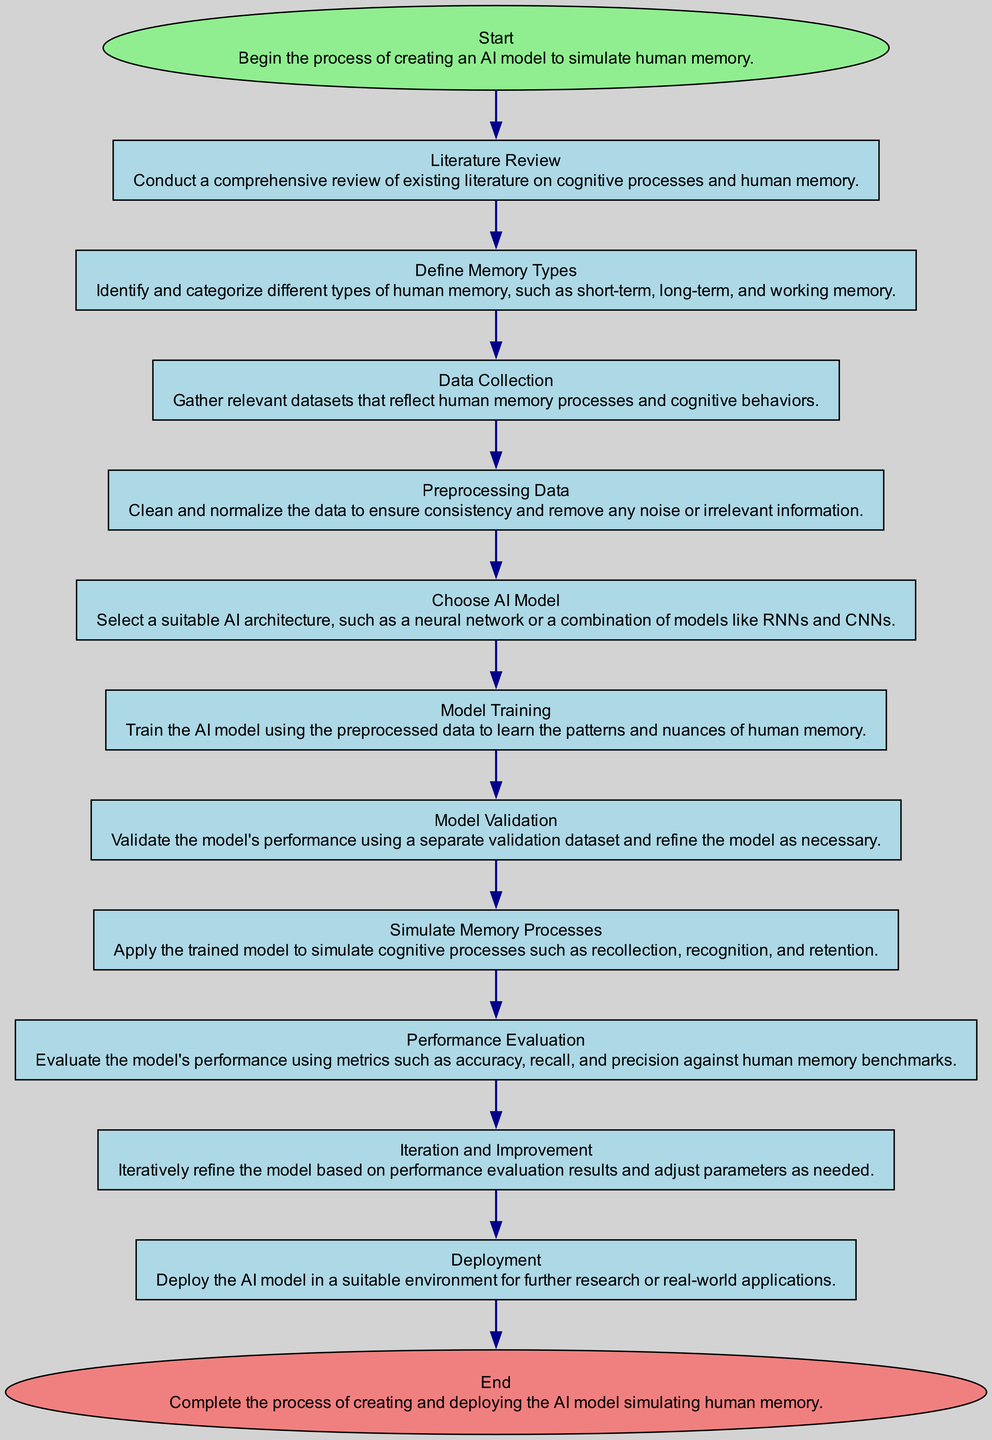What is the starting point of the flowchart? The starting point of the flowchart is identified as the first element, which is labeled "Start". This initiates the entire process of creating an AI model to simulate human memory.
Answer: Start How many nodes are in the diagram? There are a total of thirteen nodes in the diagram, each representing a distinct step in the process, from "Start" to "End".
Answer: Thirteen What is the task following "Data Collection"? The task following "Data Collection" is "Preprocessing Data". This indicates that after gathering the datasets, the next step is to clean and normalize the data.
Answer: Preprocessing Data Which two nodes are directly connected by an edge after "Model Training"? The two nodes directly connected by an edge after "Model Training" are "Model Validation" and "Model Training". The flow progresses from training the model to validating its performance.
Answer: Model Validation In what shape is the "End" node represented? The "End" node is represented in an ellipse shape, distinguishing it as the final stage of the flowchart. Ellipses are generally used to indicate the start and end of processes.
Answer: Ellipse Which step precedes "Simulate Memory Processes"? The step that precedes "Simulate Memory Processes" is "Model Validation". This means that before simulating cognitive processes, the model must first be validated.
Answer: Model Validation What is the last step in creating the AI model? The last step in creating the AI model is "End". This marks the completion of the entire process and indicates that the AI model has been created and deployed.
Answer: End What do you need to do after "Performance Evaluation"? After "Performance Evaluation", the next step is "Iteration and Improvement". This indicates that based on the performance results, the model will be refined and improved iteratively.
Answer: Iteration and Improvement What is the primary focus of the "Choose AI Model" step? The primary focus of the "Choose AI Model" step is to select the appropriate AI architecture for the task. It highlights the importance of model selection in the development of the AI model.
Answer: Choose AI Model 